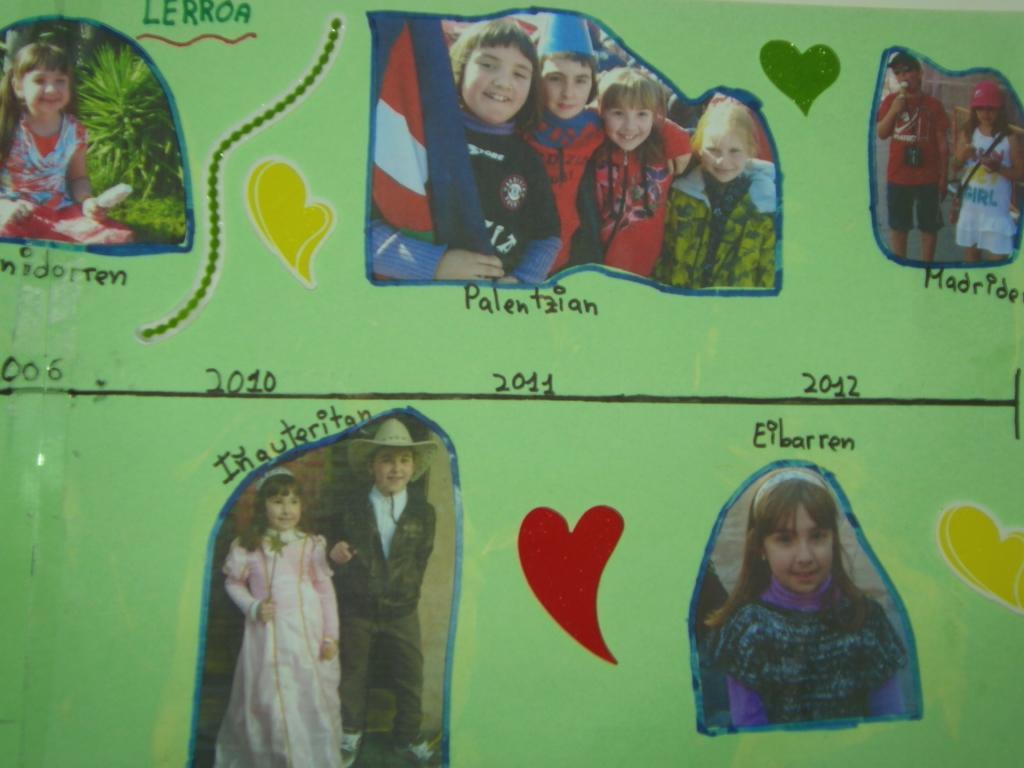Please provide a concise description of this image. In this picture, we see a green color wall on which photos of children are placed. We even see some posts are posted, We see some text written on the wall. 